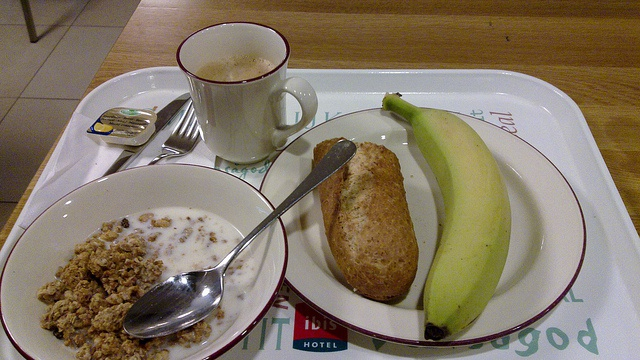Describe the objects in this image and their specific colors. I can see dining table in darkgray, olive, and gray tones, bowl in gray, darkgray, black, and olive tones, banana in gray and olive tones, cup in gray tones, and spoon in gray, black, and darkgreen tones in this image. 